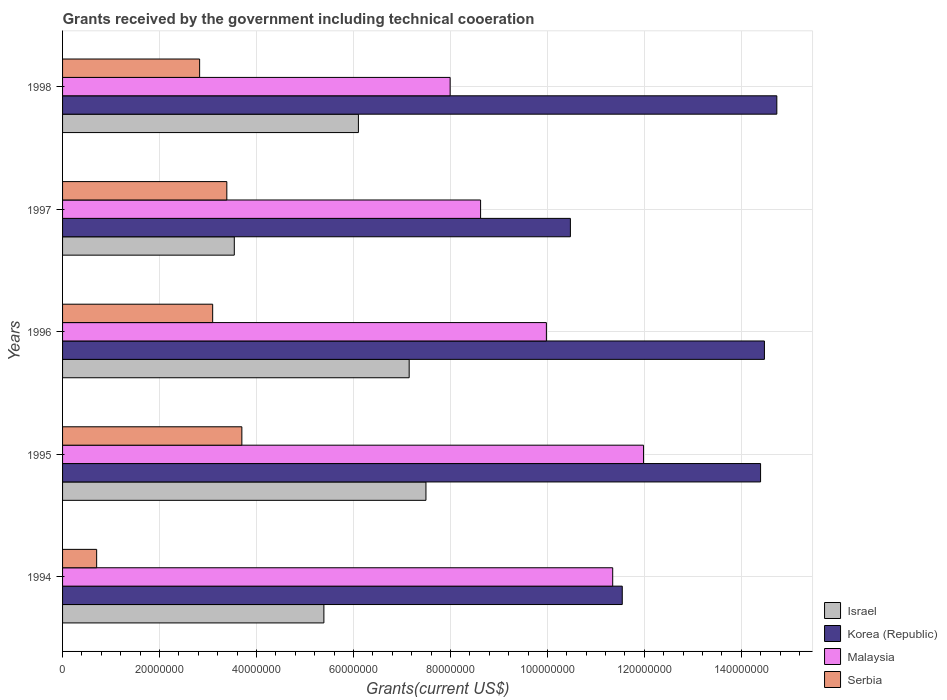How many different coloured bars are there?
Offer a very short reply. 4. How many groups of bars are there?
Make the answer very short. 5. What is the total grants received by the government in Korea (Republic) in 1994?
Keep it short and to the point. 1.15e+08. Across all years, what is the maximum total grants received by the government in Korea (Republic)?
Provide a succinct answer. 1.47e+08. Across all years, what is the minimum total grants received by the government in Israel?
Provide a succinct answer. 3.54e+07. In which year was the total grants received by the government in Serbia minimum?
Provide a succinct answer. 1994. What is the total total grants received by the government in Serbia in the graph?
Your response must be concise. 1.37e+08. What is the difference between the total grants received by the government in Israel in 1996 and that in 1997?
Your answer should be compact. 3.61e+07. What is the difference between the total grants received by the government in Korea (Republic) in 1994 and the total grants received by the government in Israel in 1995?
Keep it short and to the point. 4.05e+07. What is the average total grants received by the government in Korea (Republic) per year?
Offer a very short reply. 1.31e+08. In the year 1994, what is the difference between the total grants received by the government in Israel and total grants received by the government in Korea (Republic)?
Offer a very short reply. -6.15e+07. What is the ratio of the total grants received by the government in Malaysia in 1995 to that in 1996?
Provide a short and direct response. 1.2. What is the difference between the highest and the second highest total grants received by the government in Serbia?
Your answer should be compact. 3.10e+06. What is the difference between the highest and the lowest total grants received by the government in Serbia?
Offer a very short reply. 3.00e+07. In how many years, is the total grants received by the government in Malaysia greater than the average total grants received by the government in Malaysia taken over all years?
Your answer should be very brief. 2. Is it the case that in every year, the sum of the total grants received by the government in Serbia and total grants received by the government in Korea (Republic) is greater than the sum of total grants received by the government in Israel and total grants received by the government in Malaysia?
Your answer should be compact. No. What does the 2nd bar from the bottom in 1995 represents?
Offer a very short reply. Korea (Republic). Is it the case that in every year, the sum of the total grants received by the government in Korea (Republic) and total grants received by the government in Israel is greater than the total grants received by the government in Serbia?
Give a very brief answer. Yes. Are all the bars in the graph horizontal?
Your response must be concise. Yes. How many years are there in the graph?
Offer a very short reply. 5. What is the difference between two consecutive major ticks on the X-axis?
Provide a short and direct response. 2.00e+07. Are the values on the major ticks of X-axis written in scientific E-notation?
Ensure brevity in your answer.  No. Does the graph contain any zero values?
Offer a very short reply. No. Does the graph contain grids?
Make the answer very short. Yes. What is the title of the graph?
Offer a very short reply. Grants received by the government including technical cooeration. What is the label or title of the X-axis?
Offer a very short reply. Grants(current US$). What is the label or title of the Y-axis?
Provide a succinct answer. Years. What is the Grants(current US$) of Israel in 1994?
Offer a very short reply. 5.39e+07. What is the Grants(current US$) of Korea (Republic) in 1994?
Provide a succinct answer. 1.15e+08. What is the Grants(current US$) in Malaysia in 1994?
Offer a terse response. 1.13e+08. What is the Grants(current US$) of Serbia in 1994?
Your answer should be compact. 7.03e+06. What is the Grants(current US$) of Israel in 1995?
Your answer should be compact. 7.50e+07. What is the Grants(current US$) in Korea (Republic) in 1995?
Provide a succinct answer. 1.44e+08. What is the Grants(current US$) in Malaysia in 1995?
Ensure brevity in your answer.  1.20e+08. What is the Grants(current US$) of Serbia in 1995?
Make the answer very short. 3.70e+07. What is the Grants(current US$) of Israel in 1996?
Provide a short and direct response. 7.15e+07. What is the Grants(current US$) in Korea (Republic) in 1996?
Make the answer very short. 1.45e+08. What is the Grants(current US$) of Malaysia in 1996?
Give a very brief answer. 9.98e+07. What is the Grants(current US$) in Serbia in 1996?
Provide a short and direct response. 3.10e+07. What is the Grants(current US$) in Israel in 1997?
Ensure brevity in your answer.  3.54e+07. What is the Grants(current US$) in Korea (Republic) in 1997?
Ensure brevity in your answer.  1.05e+08. What is the Grants(current US$) of Malaysia in 1997?
Offer a terse response. 8.62e+07. What is the Grants(current US$) of Serbia in 1997?
Provide a short and direct response. 3.39e+07. What is the Grants(current US$) in Israel in 1998?
Offer a terse response. 6.10e+07. What is the Grants(current US$) in Korea (Republic) in 1998?
Ensure brevity in your answer.  1.47e+08. What is the Grants(current US$) of Malaysia in 1998?
Offer a very short reply. 7.99e+07. What is the Grants(current US$) in Serbia in 1998?
Provide a short and direct response. 2.83e+07. Across all years, what is the maximum Grants(current US$) in Israel?
Provide a succinct answer. 7.50e+07. Across all years, what is the maximum Grants(current US$) of Korea (Republic)?
Your response must be concise. 1.47e+08. Across all years, what is the maximum Grants(current US$) in Malaysia?
Your answer should be very brief. 1.20e+08. Across all years, what is the maximum Grants(current US$) in Serbia?
Offer a terse response. 3.70e+07. Across all years, what is the minimum Grants(current US$) of Israel?
Your answer should be very brief. 3.54e+07. Across all years, what is the minimum Grants(current US$) of Korea (Republic)?
Your response must be concise. 1.05e+08. Across all years, what is the minimum Grants(current US$) of Malaysia?
Provide a short and direct response. 7.99e+07. Across all years, what is the minimum Grants(current US$) in Serbia?
Your answer should be compact. 7.03e+06. What is the total Grants(current US$) in Israel in the graph?
Give a very brief answer. 2.97e+08. What is the total Grants(current US$) of Korea (Republic) in the graph?
Offer a terse response. 6.56e+08. What is the total Grants(current US$) in Malaysia in the graph?
Provide a succinct answer. 4.99e+08. What is the total Grants(current US$) in Serbia in the graph?
Your answer should be very brief. 1.37e+08. What is the difference between the Grants(current US$) in Israel in 1994 and that in 1995?
Offer a terse response. -2.10e+07. What is the difference between the Grants(current US$) of Korea (Republic) in 1994 and that in 1995?
Offer a terse response. -2.85e+07. What is the difference between the Grants(current US$) of Malaysia in 1994 and that in 1995?
Offer a very short reply. -6.36e+06. What is the difference between the Grants(current US$) in Serbia in 1994 and that in 1995?
Keep it short and to the point. -3.00e+07. What is the difference between the Grants(current US$) in Israel in 1994 and that in 1996?
Your response must be concise. -1.76e+07. What is the difference between the Grants(current US$) in Korea (Republic) in 1994 and that in 1996?
Provide a short and direct response. -2.93e+07. What is the difference between the Grants(current US$) of Malaysia in 1994 and that in 1996?
Provide a succinct answer. 1.37e+07. What is the difference between the Grants(current US$) of Serbia in 1994 and that in 1996?
Provide a short and direct response. -2.39e+07. What is the difference between the Grants(current US$) of Israel in 1994 and that in 1997?
Your answer should be compact. 1.85e+07. What is the difference between the Grants(current US$) of Korea (Republic) in 1994 and that in 1997?
Keep it short and to the point. 1.07e+07. What is the difference between the Grants(current US$) in Malaysia in 1994 and that in 1997?
Keep it short and to the point. 2.72e+07. What is the difference between the Grants(current US$) of Serbia in 1994 and that in 1997?
Keep it short and to the point. -2.68e+07. What is the difference between the Grants(current US$) of Israel in 1994 and that in 1998?
Ensure brevity in your answer.  -7.12e+06. What is the difference between the Grants(current US$) in Korea (Republic) in 1994 and that in 1998?
Offer a very short reply. -3.19e+07. What is the difference between the Grants(current US$) of Malaysia in 1994 and that in 1998?
Make the answer very short. 3.35e+07. What is the difference between the Grants(current US$) of Serbia in 1994 and that in 1998?
Keep it short and to the point. -2.12e+07. What is the difference between the Grants(current US$) in Israel in 1995 and that in 1996?
Provide a short and direct response. 3.46e+06. What is the difference between the Grants(current US$) in Korea (Republic) in 1995 and that in 1996?
Provide a short and direct response. -7.90e+05. What is the difference between the Grants(current US$) of Malaysia in 1995 and that in 1996?
Offer a very short reply. 2.00e+07. What is the difference between the Grants(current US$) of Serbia in 1995 and that in 1996?
Provide a succinct answer. 6.02e+06. What is the difference between the Grants(current US$) in Israel in 1995 and that in 1997?
Give a very brief answer. 3.95e+07. What is the difference between the Grants(current US$) of Korea (Republic) in 1995 and that in 1997?
Your response must be concise. 3.92e+07. What is the difference between the Grants(current US$) of Malaysia in 1995 and that in 1997?
Your response must be concise. 3.36e+07. What is the difference between the Grants(current US$) in Serbia in 1995 and that in 1997?
Provide a short and direct response. 3.10e+06. What is the difference between the Grants(current US$) of Israel in 1995 and that in 1998?
Your answer should be very brief. 1.39e+07. What is the difference between the Grants(current US$) in Korea (Republic) in 1995 and that in 1998?
Provide a succinct answer. -3.35e+06. What is the difference between the Grants(current US$) in Malaysia in 1995 and that in 1998?
Provide a succinct answer. 3.99e+07. What is the difference between the Grants(current US$) in Serbia in 1995 and that in 1998?
Make the answer very short. 8.71e+06. What is the difference between the Grants(current US$) in Israel in 1996 and that in 1997?
Offer a terse response. 3.61e+07. What is the difference between the Grants(current US$) of Korea (Republic) in 1996 and that in 1997?
Offer a terse response. 4.00e+07. What is the difference between the Grants(current US$) in Malaysia in 1996 and that in 1997?
Keep it short and to the point. 1.36e+07. What is the difference between the Grants(current US$) in Serbia in 1996 and that in 1997?
Give a very brief answer. -2.92e+06. What is the difference between the Grants(current US$) of Israel in 1996 and that in 1998?
Your response must be concise. 1.05e+07. What is the difference between the Grants(current US$) in Korea (Republic) in 1996 and that in 1998?
Provide a short and direct response. -2.56e+06. What is the difference between the Grants(current US$) in Malaysia in 1996 and that in 1998?
Your answer should be very brief. 1.98e+07. What is the difference between the Grants(current US$) in Serbia in 1996 and that in 1998?
Your response must be concise. 2.69e+06. What is the difference between the Grants(current US$) of Israel in 1997 and that in 1998?
Provide a succinct answer. -2.56e+07. What is the difference between the Grants(current US$) in Korea (Republic) in 1997 and that in 1998?
Provide a short and direct response. -4.26e+07. What is the difference between the Grants(current US$) in Malaysia in 1997 and that in 1998?
Your answer should be very brief. 6.28e+06. What is the difference between the Grants(current US$) in Serbia in 1997 and that in 1998?
Provide a succinct answer. 5.61e+06. What is the difference between the Grants(current US$) of Israel in 1994 and the Grants(current US$) of Korea (Republic) in 1995?
Keep it short and to the point. -9.01e+07. What is the difference between the Grants(current US$) of Israel in 1994 and the Grants(current US$) of Malaysia in 1995?
Offer a very short reply. -6.59e+07. What is the difference between the Grants(current US$) in Israel in 1994 and the Grants(current US$) in Serbia in 1995?
Keep it short and to the point. 1.69e+07. What is the difference between the Grants(current US$) of Korea (Republic) in 1994 and the Grants(current US$) of Malaysia in 1995?
Offer a terse response. -4.39e+06. What is the difference between the Grants(current US$) in Korea (Republic) in 1994 and the Grants(current US$) in Serbia in 1995?
Ensure brevity in your answer.  7.85e+07. What is the difference between the Grants(current US$) in Malaysia in 1994 and the Grants(current US$) in Serbia in 1995?
Provide a succinct answer. 7.65e+07. What is the difference between the Grants(current US$) in Israel in 1994 and the Grants(current US$) in Korea (Republic) in 1996?
Your answer should be compact. -9.09e+07. What is the difference between the Grants(current US$) of Israel in 1994 and the Grants(current US$) of Malaysia in 1996?
Keep it short and to the point. -4.59e+07. What is the difference between the Grants(current US$) of Israel in 1994 and the Grants(current US$) of Serbia in 1996?
Give a very brief answer. 2.29e+07. What is the difference between the Grants(current US$) of Korea (Republic) in 1994 and the Grants(current US$) of Malaysia in 1996?
Ensure brevity in your answer.  1.56e+07. What is the difference between the Grants(current US$) of Korea (Republic) in 1994 and the Grants(current US$) of Serbia in 1996?
Provide a short and direct response. 8.45e+07. What is the difference between the Grants(current US$) of Malaysia in 1994 and the Grants(current US$) of Serbia in 1996?
Keep it short and to the point. 8.25e+07. What is the difference between the Grants(current US$) in Israel in 1994 and the Grants(current US$) in Korea (Republic) in 1997?
Provide a succinct answer. -5.08e+07. What is the difference between the Grants(current US$) of Israel in 1994 and the Grants(current US$) of Malaysia in 1997?
Your response must be concise. -3.23e+07. What is the difference between the Grants(current US$) in Israel in 1994 and the Grants(current US$) in Serbia in 1997?
Offer a very short reply. 2.00e+07. What is the difference between the Grants(current US$) in Korea (Republic) in 1994 and the Grants(current US$) in Malaysia in 1997?
Make the answer very short. 2.92e+07. What is the difference between the Grants(current US$) of Korea (Republic) in 1994 and the Grants(current US$) of Serbia in 1997?
Offer a terse response. 8.16e+07. What is the difference between the Grants(current US$) of Malaysia in 1994 and the Grants(current US$) of Serbia in 1997?
Ensure brevity in your answer.  7.96e+07. What is the difference between the Grants(current US$) in Israel in 1994 and the Grants(current US$) in Korea (Republic) in 1998?
Provide a short and direct response. -9.34e+07. What is the difference between the Grants(current US$) of Israel in 1994 and the Grants(current US$) of Malaysia in 1998?
Offer a terse response. -2.60e+07. What is the difference between the Grants(current US$) of Israel in 1994 and the Grants(current US$) of Serbia in 1998?
Keep it short and to the point. 2.56e+07. What is the difference between the Grants(current US$) of Korea (Republic) in 1994 and the Grants(current US$) of Malaysia in 1998?
Make the answer very short. 3.55e+07. What is the difference between the Grants(current US$) of Korea (Republic) in 1994 and the Grants(current US$) of Serbia in 1998?
Your response must be concise. 8.72e+07. What is the difference between the Grants(current US$) of Malaysia in 1994 and the Grants(current US$) of Serbia in 1998?
Provide a succinct answer. 8.52e+07. What is the difference between the Grants(current US$) in Israel in 1995 and the Grants(current US$) in Korea (Republic) in 1996?
Your answer should be compact. -6.98e+07. What is the difference between the Grants(current US$) of Israel in 1995 and the Grants(current US$) of Malaysia in 1996?
Keep it short and to the point. -2.48e+07. What is the difference between the Grants(current US$) of Israel in 1995 and the Grants(current US$) of Serbia in 1996?
Make the answer very short. 4.40e+07. What is the difference between the Grants(current US$) in Korea (Republic) in 1995 and the Grants(current US$) in Malaysia in 1996?
Your answer should be very brief. 4.42e+07. What is the difference between the Grants(current US$) in Korea (Republic) in 1995 and the Grants(current US$) in Serbia in 1996?
Your answer should be very brief. 1.13e+08. What is the difference between the Grants(current US$) in Malaysia in 1995 and the Grants(current US$) in Serbia in 1996?
Your answer should be very brief. 8.89e+07. What is the difference between the Grants(current US$) in Israel in 1995 and the Grants(current US$) in Korea (Republic) in 1997?
Offer a very short reply. -2.98e+07. What is the difference between the Grants(current US$) in Israel in 1995 and the Grants(current US$) in Malaysia in 1997?
Your answer should be very brief. -1.13e+07. What is the difference between the Grants(current US$) of Israel in 1995 and the Grants(current US$) of Serbia in 1997?
Provide a succinct answer. 4.11e+07. What is the difference between the Grants(current US$) of Korea (Republic) in 1995 and the Grants(current US$) of Malaysia in 1997?
Your response must be concise. 5.78e+07. What is the difference between the Grants(current US$) of Korea (Republic) in 1995 and the Grants(current US$) of Serbia in 1997?
Your response must be concise. 1.10e+08. What is the difference between the Grants(current US$) in Malaysia in 1995 and the Grants(current US$) in Serbia in 1997?
Your answer should be very brief. 8.60e+07. What is the difference between the Grants(current US$) in Israel in 1995 and the Grants(current US$) in Korea (Republic) in 1998?
Offer a very short reply. -7.24e+07. What is the difference between the Grants(current US$) of Israel in 1995 and the Grants(current US$) of Malaysia in 1998?
Provide a short and direct response. -4.99e+06. What is the difference between the Grants(current US$) of Israel in 1995 and the Grants(current US$) of Serbia in 1998?
Your answer should be compact. 4.67e+07. What is the difference between the Grants(current US$) of Korea (Republic) in 1995 and the Grants(current US$) of Malaysia in 1998?
Your answer should be compact. 6.40e+07. What is the difference between the Grants(current US$) of Korea (Republic) in 1995 and the Grants(current US$) of Serbia in 1998?
Your answer should be compact. 1.16e+08. What is the difference between the Grants(current US$) in Malaysia in 1995 and the Grants(current US$) in Serbia in 1998?
Your response must be concise. 9.16e+07. What is the difference between the Grants(current US$) in Israel in 1996 and the Grants(current US$) in Korea (Republic) in 1997?
Your answer should be very brief. -3.32e+07. What is the difference between the Grants(current US$) in Israel in 1996 and the Grants(current US$) in Malaysia in 1997?
Offer a terse response. -1.47e+07. What is the difference between the Grants(current US$) of Israel in 1996 and the Grants(current US$) of Serbia in 1997?
Provide a succinct answer. 3.76e+07. What is the difference between the Grants(current US$) in Korea (Republic) in 1996 and the Grants(current US$) in Malaysia in 1997?
Offer a terse response. 5.85e+07. What is the difference between the Grants(current US$) of Korea (Republic) in 1996 and the Grants(current US$) of Serbia in 1997?
Your response must be concise. 1.11e+08. What is the difference between the Grants(current US$) of Malaysia in 1996 and the Grants(current US$) of Serbia in 1997?
Your answer should be compact. 6.59e+07. What is the difference between the Grants(current US$) in Israel in 1996 and the Grants(current US$) in Korea (Republic) in 1998?
Your response must be concise. -7.58e+07. What is the difference between the Grants(current US$) in Israel in 1996 and the Grants(current US$) in Malaysia in 1998?
Keep it short and to the point. -8.45e+06. What is the difference between the Grants(current US$) of Israel in 1996 and the Grants(current US$) of Serbia in 1998?
Provide a short and direct response. 4.32e+07. What is the difference between the Grants(current US$) of Korea (Republic) in 1996 and the Grants(current US$) of Malaysia in 1998?
Offer a terse response. 6.48e+07. What is the difference between the Grants(current US$) of Korea (Republic) in 1996 and the Grants(current US$) of Serbia in 1998?
Your answer should be very brief. 1.16e+08. What is the difference between the Grants(current US$) of Malaysia in 1996 and the Grants(current US$) of Serbia in 1998?
Your response must be concise. 7.15e+07. What is the difference between the Grants(current US$) of Israel in 1997 and the Grants(current US$) of Korea (Republic) in 1998?
Offer a very short reply. -1.12e+08. What is the difference between the Grants(current US$) in Israel in 1997 and the Grants(current US$) in Malaysia in 1998?
Keep it short and to the point. -4.45e+07. What is the difference between the Grants(current US$) in Israel in 1997 and the Grants(current US$) in Serbia in 1998?
Ensure brevity in your answer.  7.15e+06. What is the difference between the Grants(current US$) in Korea (Republic) in 1997 and the Grants(current US$) in Malaysia in 1998?
Give a very brief answer. 2.48e+07. What is the difference between the Grants(current US$) in Korea (Republic) in 1997 and the Grants(current US$) in Serbia in 1998?
Your answer should be very brief. 7.65e+07. What is the difference between the Grants(current US$) of Malaysia in 1997 and the Grants(current US$) of Serbia in 1998?
Offer a terse response. 5.80e+07. What is the average Grants(current US$) in Israel per year?
Make the answer very short. 5.94e+07. What is the average Grants(current US$) of Korea (Republic) per year?
Give a very brief answer. 1.31e+08. What is the average Grants(current US$) in Malaysia per year?
Provide a succinct answer. 9.98e+07. What is the average Grants(current US$) of Serbia per year?
Provide a short and direct response. 2.74e+07. In the year 1994, what is the difference between the Grants(current US$) in Israel and Grants(current US$) in Korea (Republic)?
Ensure brevity in your answer.  -6.15e+07. In the year 1994, what is the difference between the Grants(current US$) of Israel and Grants(current US$) of Malaysia?
Ensure brevity in your answer.  -5.96e+07. In the year 1994, what is the difference between the Grants(current US$) in Israel and Grants(current US$) in Serbia?
Offer a very short reply. 4.69e+07. In the year 1994, what is the difference between the Grants(current US$) in Korea (Republic) and Grants(current US$) in Malaysia?
Offer a very short reply. 1.97e+06. In the year 1994, what is the difference between the Grants(current US$) in Korea (Republic) and Grants(current US$) in Serbia?
Give a very brief answer. 1.08e+08. In the year 1994, what is the difference between the Grants(current US$) of Malaysia and Grants(current US$) of Serbia?
Provide a succinct answer. 1.06e+08. In the year 1995, what is the difference between the Grants(current US$) of Israel and Grants(current US$) of Korea (Republic)?
Keep it short and to the point. -6.90e+07. In the year 1995, what is the difference between the Grants(current US$) in Israel and Grants(current US$) in Malaysia?
Provide a short and direct response. -4.49e+07. In the year 1995, what is the difference between the Grants(current US$) in Israel and Grants(current US$) in Serbia?
Ensure brevity in your answer.  3.80e+07. In the year 1995, what is the difference between the Grants(current US$) of Korea (Republic) and Grants(current US$) of Malaysia?
Provide a succinct answer. 2.41e+07. In the year 1995, what is the difference between the Grants(current US$) in Korea (Republic) and Grants(current US$) in Serbia?
Your answer should be very brief. 1.07e+08. In the year 1995, what is the difference between the Grants(current US$) of Malaysia and Grants(current US$) of Serbia?
Your answer should be very brief. 8.28e+07. In the year 1996, what is the difference between the Grants(current US$) of Israel and Grants(current US$) of Korea (Republic)?
Your answer should be compact. -7.33e+07. In the year 1996, what is the difference between the Grants(current US$) in Israel and Grants(current US$) in Malaysia?
Ensure brevity in your answer.  -2.83e+07. In the year 1996, what is the difference between the Grants(current US$) in Israel and Grants(current US$) in Serbia?
Your response must be concise. 4.05e+07. In the year 1996, what is the difference between the Grants(current US$) in Korea (Republic) and Grants(current US$) in Malaysia?
Provide a succinct answer. 4.50e+07. In the year 1996, what is the difference between the Grants(current US$) of Korea (Republic) and Grants(current US$) of Serbia?
Offer a very short reply. 1.14e+08. In the year 1996, what is the difference between the Grants(current US$) in Malaysia and Grants(current US$) in Serbia?
Offer a very short reply. 6.88e+07. In the year 1997, what is the difference between the Grants(current US$) in Israel and Grants(current US$) in Korea (Republic)?
Offer a terse response. -6.93e+07. In the year 1997, what is the difference between the Grants(current US$) in Israel and Grants(current US$) in Malaysia?
Make the answer very short. -5.08e+07. In the year 1997, what is the difference between the Grants(current US$) in Israel and Grants(current US$) in Serbia?
Your response must be concise. 1.54e+06. In the year 1997, what is the difference between the Grants(current US$) in Korea (Republic) and Grants(current US$) in Malaysia?
Make the answer very short. 1.85e+07. In the year 1997, what is the difference between the Grants(current US$) in Korea (Republic) and Grants(current US$) in Serbia?
Your response must be concise. 7.09e+07. In the year 1997, what is the difference between the Grants(current US$) in Malaysia and Grants(current US$) in Serbia?
Ensure brevity in your answer.  5.23e+07. In the year 1998, what is the difference between the Grants(current US$) in Israel and Grants(current US$) in Korea (Republic)?
Ensure brevity in your answer.  -8.63e+07. In the year 1998, what is the difference between the Grants(current US$) in Israel and Grants(current US$) in Malaysia?
Your answer should be compact. -1.89e+07. In the year 1998, what is the difference between the Grants(current US$) in Israel and Grants(current US$) in Serbia?
Offer a terse response. 3.28e+07. In the year 1998, what is the difference between the Grants(current US$) in Korea (Republic) and Grants(current US$) in Malaysia?
Keep it short and to the point. 6.74e+07. In the year 1998, what is the difference between the Grants(current US$) in Korea (Republic) and Grants(current US$) in Serbia?
Ensure brevity in your answer.  1.19e+08. In the year 1998, what is the difference between the Grants(current US$) of Malaysia and Grants(current US$) of Serbia?
Provide a succinct answer. 5.17e+07. What is the ratio of the Grants(current US$) in Israel in 1994 to that in 1995?
Offer a terse response. 0.72. What is the ratio of the Grants(current US$) of Korea (Republic) in 1994 to that in 1995?
Provide a succinct answer. 0.8. What is the ratio of the Grants(current US$) of Malaysia in 1994 to that in 1995?
Offer a very short reply. 0.95. What is the ratio of the Grants(current US$) of Serbia in 1994 to that in 1995?
Your answer should be compact. 0.19. What is the ratio of the Grants(current US$) in Israel in 1994 to that in 1996?
Provide a short and direct response. 0.75. What is the ratio of the Grants(current US$) in Korea (Republic) in 1994 to that in 1996?
Make the answer very short. 0.8. What is the ratio of the Grants(current US$) in Malaysia in 1994 to that in 1996?
Your answer should be compact. 1.14. What is the ratio of the Grants(current US$) in Serbia in 1994 to that in 1996?
Offer a very short reply. 0.23. What is the ratio of the Grants(current US$) of Israel in 1994 to that in 1997?
Your response must be concise. 1.52. What is the ratio of the Grants(current US$) of Korea (Republic) in 1994 to that in 1997?
Ensure brevity in your answer.  1.1. What is the ratio of the Grants(current US$) of Malaysia in 1994 to that in 1997?
Keep it short and to the point. 1.32. What is the ratio of the Grants(current US$) of Serbia in 1994 to that in 1997?
Make the answer very short. 0.21. What is the ratio of the Grants(current US$) in Israel in 1994 to that in 1998?
Provide a short and direct response. 0.88. What is the ratio of the Grants(current US$) in Korea (Republic) in 1994 to that in 1998?
Ensure brevity in your answer.  0.78. What is the ratio of the Grants(current US$) of Malaysia in 1994 to that in 1998?
Make the answer very short. 1.42. What is the ratio of the Grants(current US$) in Serbia in 1994 to that in 1998?
Your answer should be compact. 0.25. What is the ratio of the Grants(current US$) of Israel in 1995 to that in 1996?
Give a very brief answer. 1.05. What is the ratio of the Grants(current US$) in Korea (Republic) in 1995 to that in 1996?
Ensure brevity in your answer.  0.99. What is the ratio of the Grants(current US$) of Malaysia in 1995 to that in 1996?
Your answer should be compact. 1.2. What is the ratio of the Grants(current US$) in Serbia in 1995 to that in 1996?
Keep it short and to the point. 1.19. What is the ratio of the Grants(current US$) of Israel in 1995 to that in 1997?
Keep it short and to the point. 2.12. What is the ratio of the Grants(current US$) in Korea (Republic) in 1995 to that in 1997?
Your response must be concise. 1.37. What is the ratio of the Grants(current US$) of Malaysia in 1995 to that in 1997?
Provide a succinct answer. 1.39. What is the ratio of the Grants(current US$) of Serbia in 1995 to that in 1997?
Make the answer very short. 1.09. What is the ratio of the Grants(current US$) in Israel in 1995 to that in 1998?
Provide a short and direct response. 1.23. What is the ratio of the Grants(current US$) of Korea (Republic) in 1995 to that in 1998?
Offer a very short reply. 0.98. What is the ratio of the Grants(current US$) of Malaysia in 1995 to that in 1998?
Offer a terse response. 1.5. What is the ratio of the Grants(current US$) of Serbia in 1995 to that in 1998?
Make the answer very short. 1.31. What is the ratio of the Grants(current US$) in Israel in 1996 to that in 1997?
Offer a terse response. 2.02. What is the ratio of the Grants(current US$) in Korea (Republic) in 1996 to that in 1997?
Offer a terse response. 1.38. What is the ratio of the Grants(current US$) of Malaysia in 1996 to that in 1997?
Give a very brief answer. 1.16. What is the ratio of the Grants(current US$) of Serbia in 1996 to that in 1997?
Give a very brief answer. 0.91. What is the ratio of the Grants(current US$) of Israel in 1996 to that in 1998?
Give a very brief answer. 1.17. What is the ratio of the Grants(current US$) of Korea (Republic) in 1996 to that in 1998?
Your response must be concise. 0.98. What is the ratio of the Grants(current US$) in Malaysia in 1996 to that in 1998?
Keep it short and to the point. 1.25. What is the ratio of the Grants(current US$) of Serbia in 1996 to that in 1998?
Make the answer very short. 1.1. What is the ratio of the Grants(current US$) in Israel in 1997 to that in 1998?
Provide a succinct answer. 0.58. What is the ratio of the Grants(current US$) of Korea (Republic) in 1997 to that in 1998?
Your answer should be compact. 0.71. What is the ratio of the Grants(current US$) of Malaysia in 1997 to that in 1998?
Ensure brevity in your answer.  1.08. What is the ratio of the Grants(current US$) in Serbia in 1997 to that in 1998?
Make the answer very short. 1.2. What is the difference between the highest and the second highest Grants(current US$) in Israel?
Offer a very short reply. 3.46e+06. What is the difference between the highest and the second highest Grants(current US$) of Korea (Republic)?
Your answer should be compact. 2.56e+06. What is the difference between the highest and the second highest Grants(current US$) of Malaysia?
Provide a short and direct response. 6.36e+06. What is the difference between the highest and the second highest Grants(current US$) of Serbia?
Your answer should be very brief. 3.10e+06. What is the difference between the highest and the lowest Grants(current US$) of Israel?
Your answer should be very brief. 3.95e+07. What is the difference between the highest and the lowest Grants(current US$) in Korea (Republic)?
Your answer should be very brief. 4.26e+07. What is the difference between the highest and the lowest Grants(current US$) in Malaysia?
Make the answer very short. 3.99e+07. What is the difference between the highest and the lowest Grants(current US$) in Serbia?
Provide a short and direct response. 3.00e+07. 